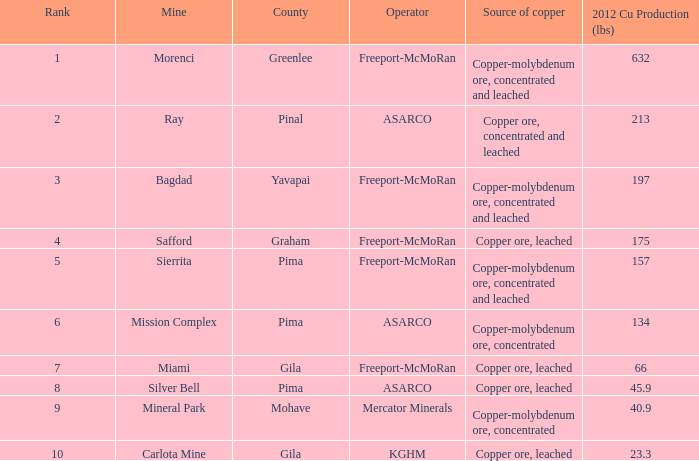What's the poorest quality source of copper, copper ore, concentrated and leached? 2.0. 